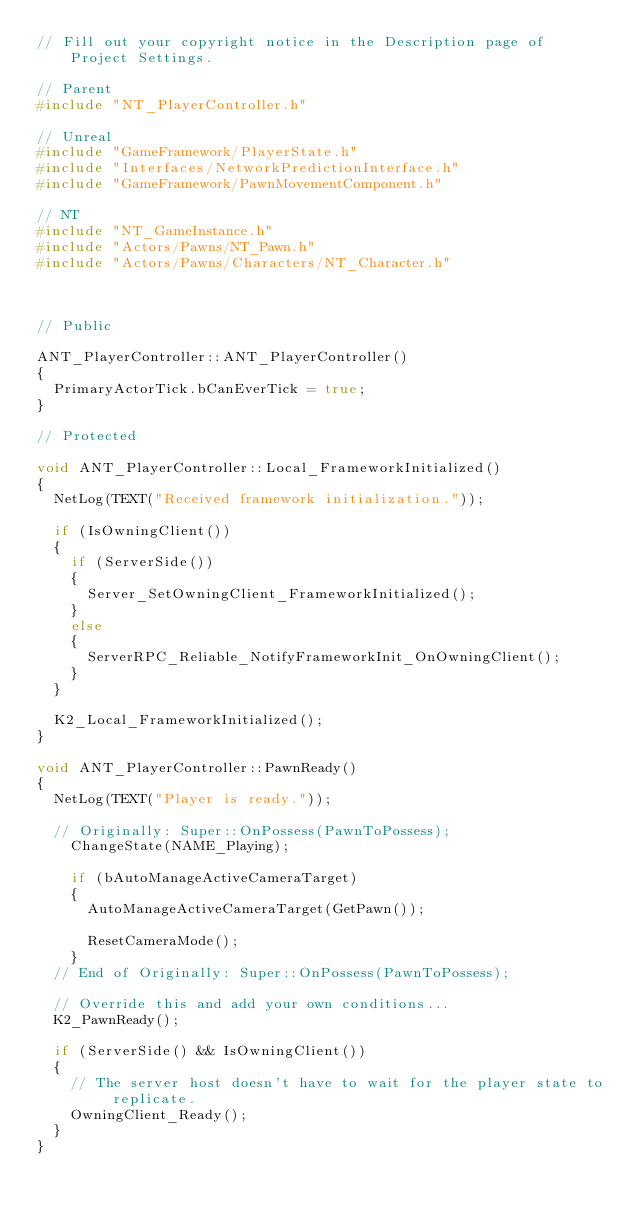<code> <loc_0><loc_0><loc_500><loc_500><_C++_>// Fill out your copyright notice in the Description page of Project Settings.

// Parent
#include "NT_PlayerController.h"

// Unreal
#include "GameFramework/PlayerState.h"
#include "Interfaces/NetworkPredictionInterface.h"
#include "GameFramework/PawnMovementComponent.h"

// NT
#include "NT_GameInstance.h"
#include "Actors/Pawns/NT_Pawn.h"
#include "Actors/Pawns/Characters/NT_Character.h"



// Public

ANT_PlayerController::ANT_PlayerController()
{
	PrimaryActorTick.bCanEverTick = true;
}

// Protected

void ANT_PlayerController::Local_FrameworkInitialized()
{
	NetLog(TEXT("Received framework initialization."));

	if (IsOwningClient())
	{
		if (ServerSide())
		{
			Server_SetOwningClient_FrameworkInitialized();
		}
		else
		{
			ServerRPC_Reliable_NotifyFrameworkInit_OnOwningClient();
		}
	}

	K2_Local_FrameworkInitialized();
}

void ANT_PlayerController::PawnReady()
{
	NetLog(TEXT("Player is ready."));

	// Originally: Super::OnPossess(PawnToPossess);
		ChangeState(NAME_Playing);

		if (bAutoManageActiveCameraTarget)
		{
			AutoManageActiveCameraTarget(GetPawn());

			ResetCameraMode();
		}
	// End of Originally: Super::OnPossess(PawnToPossess);

	// Override this and add your own conditions...
	K2_PawnReady();

	if (ServerSide() && IsOwningClient())
	{
		// The server host doesn't have to wait for the player state to replicate.
		OwningClient_Ready();
	}
}
</code> 